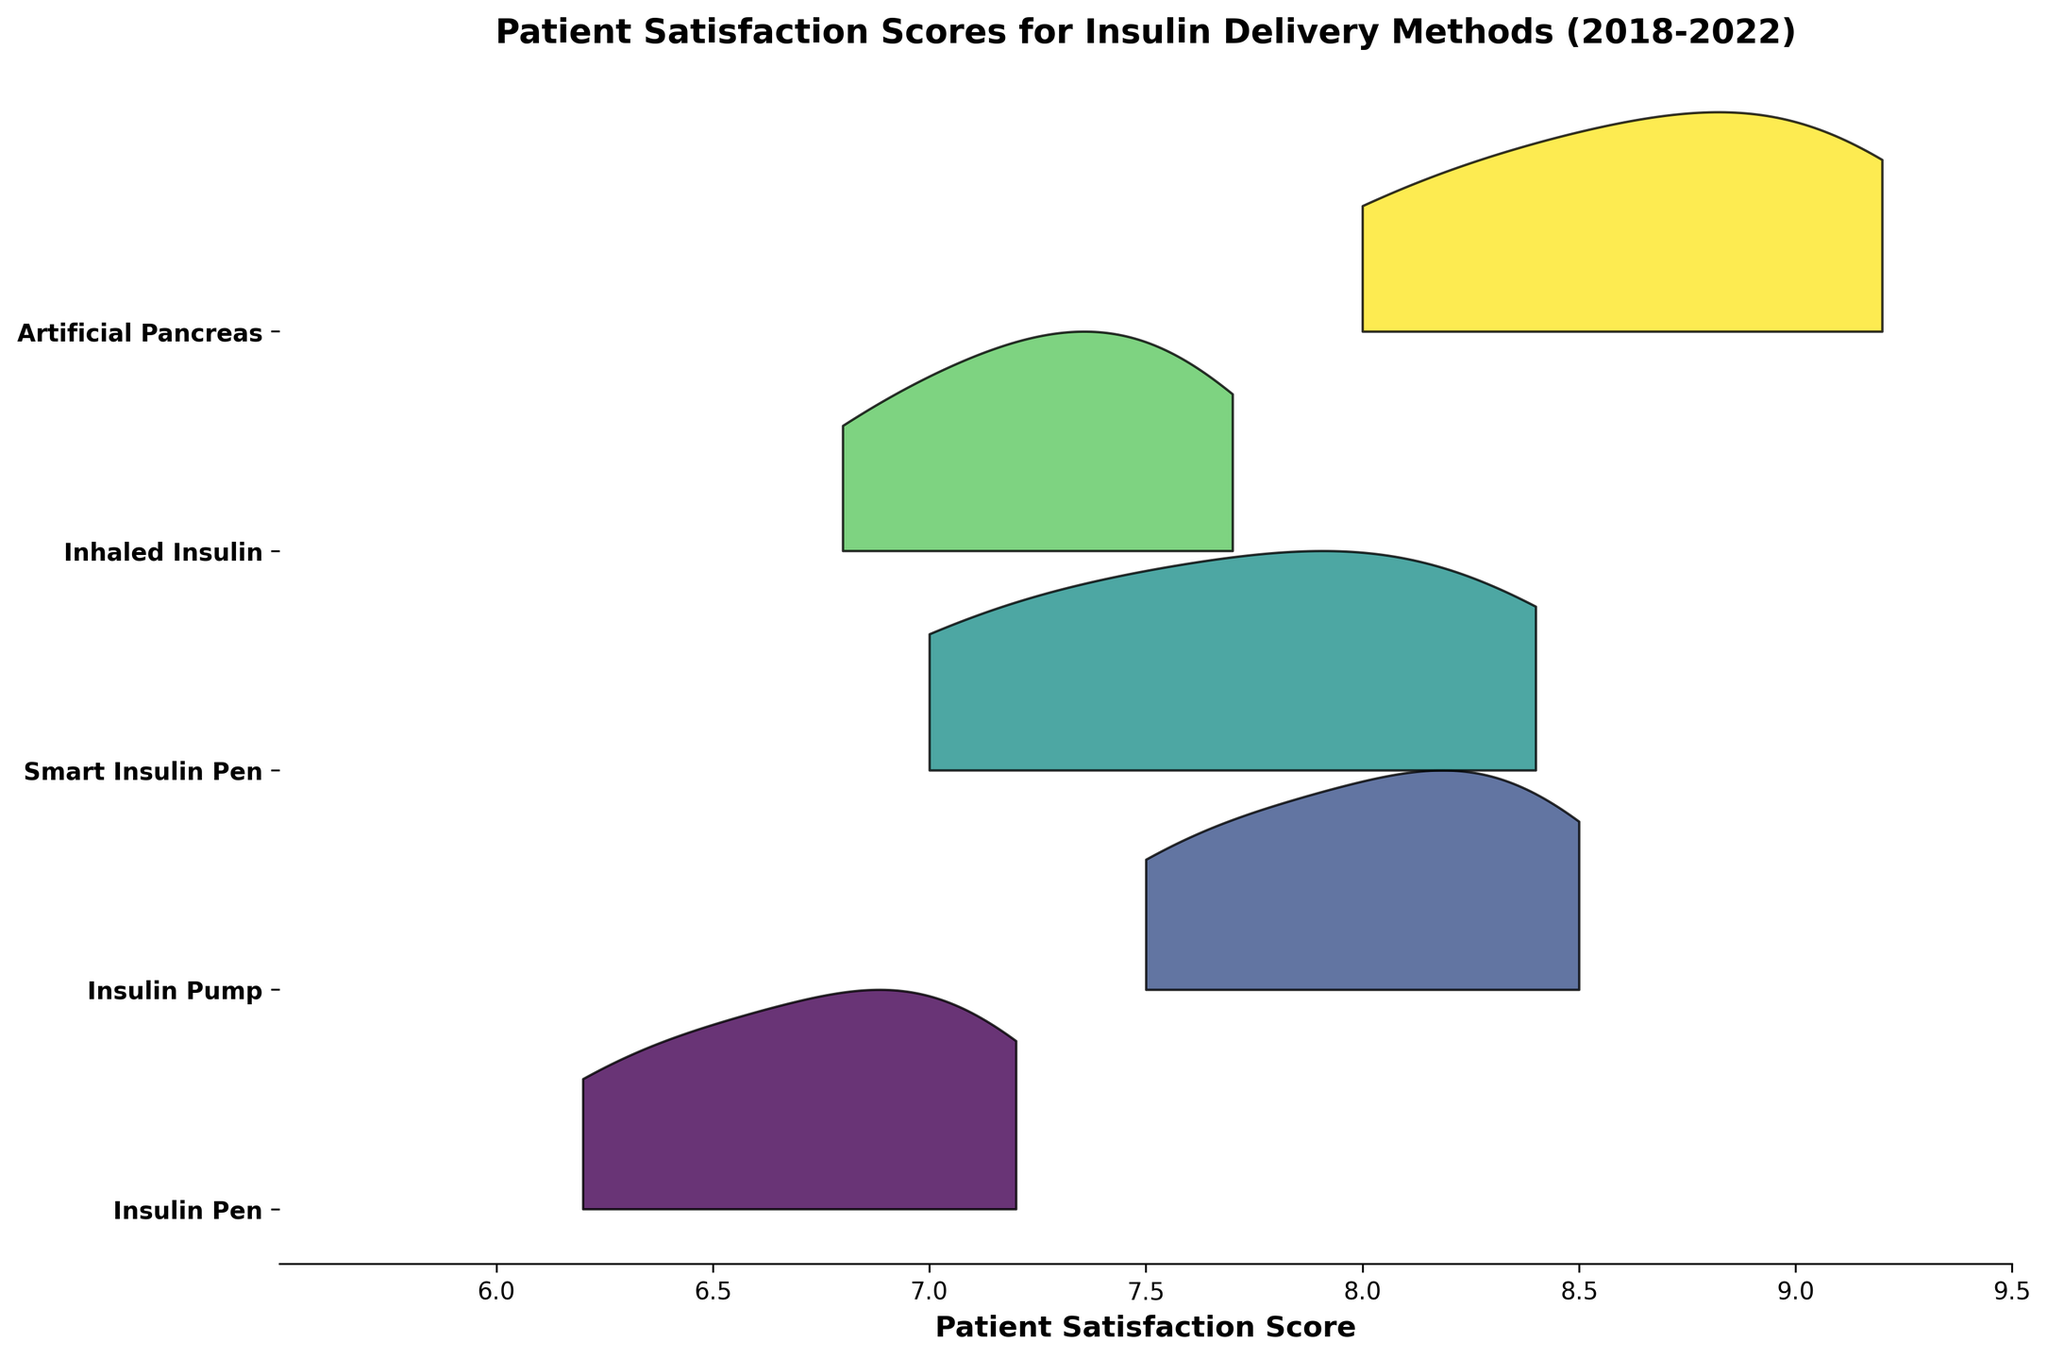What is the title of the plot? Look at the top center of the figure where the title is displayed. The title describes the overall content of the plot.
Answer: "Patient Satisfaction Scores for Insulin Delivery Methods (2018-2022)" Which method has the highest satisfaction score in 2022? Observe the figure and locate the satisfaction scores for each method in 2022. Identify the highest one.
Answer: Artificial Pancreas What is the patient satisfaction score for the Insulin Pump in 2020? Find the section representing the Insulin Pump and locate the score corresponding to the year 2020.
Answer: 8.1 Between the years 2018 and 2022, by how much did the satisfaction score for Inhaled Insulin increase? Compare the satisfaction score for Inhaled Insulin in 2018 and 2022, then calculate the difference.
Answer: 0.9 Which insulin delivery method shows the fastest rate of increase in patient satisfaction over the years? Compare the slopes of the satisfaction scores for all methods from 2018 to 2022 and identify the steepest one.
Answer: Artificial Pancreas What range of patient satisfaction scores does the Insulin Pen cover? Observe the section for the Insulin Pen and identify the lowest and highest scores presented.
Answer: 6.2 - 7.2 How does the patient satisfaction score for Smart Insulin Pen in 2021 compare to that of Insulin Pen in 2021? Locate the scores for Smart Insulin Pen and Insulin Pen in 2021 and compare them.
Answer: Higher Which method has the least variation in patient satisfaction score over the years 2018-2022? Observe the width of the distribution (variance) for each method and identify the one with the narrowest spread.
Answer: Insulin Pen Between Insulin Pump and Inhaled Insulin, which has higher patient satisfaction scores from 2018 to 2022? Compare the satisfaction scores for Insulin Pump and Inhaled Insulin for each year from 2018 to 2022.
Answer: Insulin Pump Does any method have a satisfaction score below 6 in any year from 2018 to 2022? Check all the sections and satisfaction scores from 2018 to 2022 to see if any value falls below 6.
Answer: No 